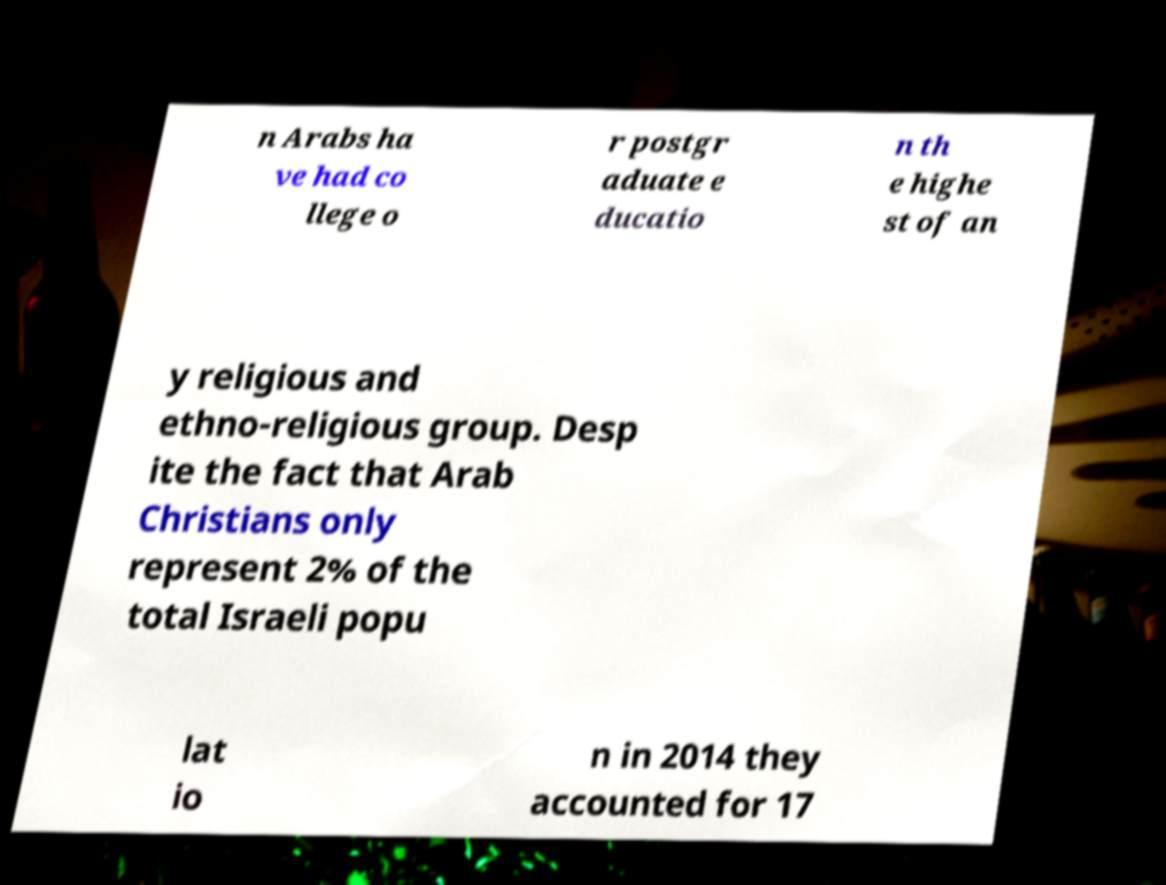What messages or text are displayed in this image? I need them in a readable, typed format. n Arabs ha ve had co llege o r postgr aduate e ducatio n th e highe st of an y religious and ethno-religious group. Desp ite the fact that Arab Christians only represent 2% of the total Israeli popu lat io n in 2014 they accounted for 17 